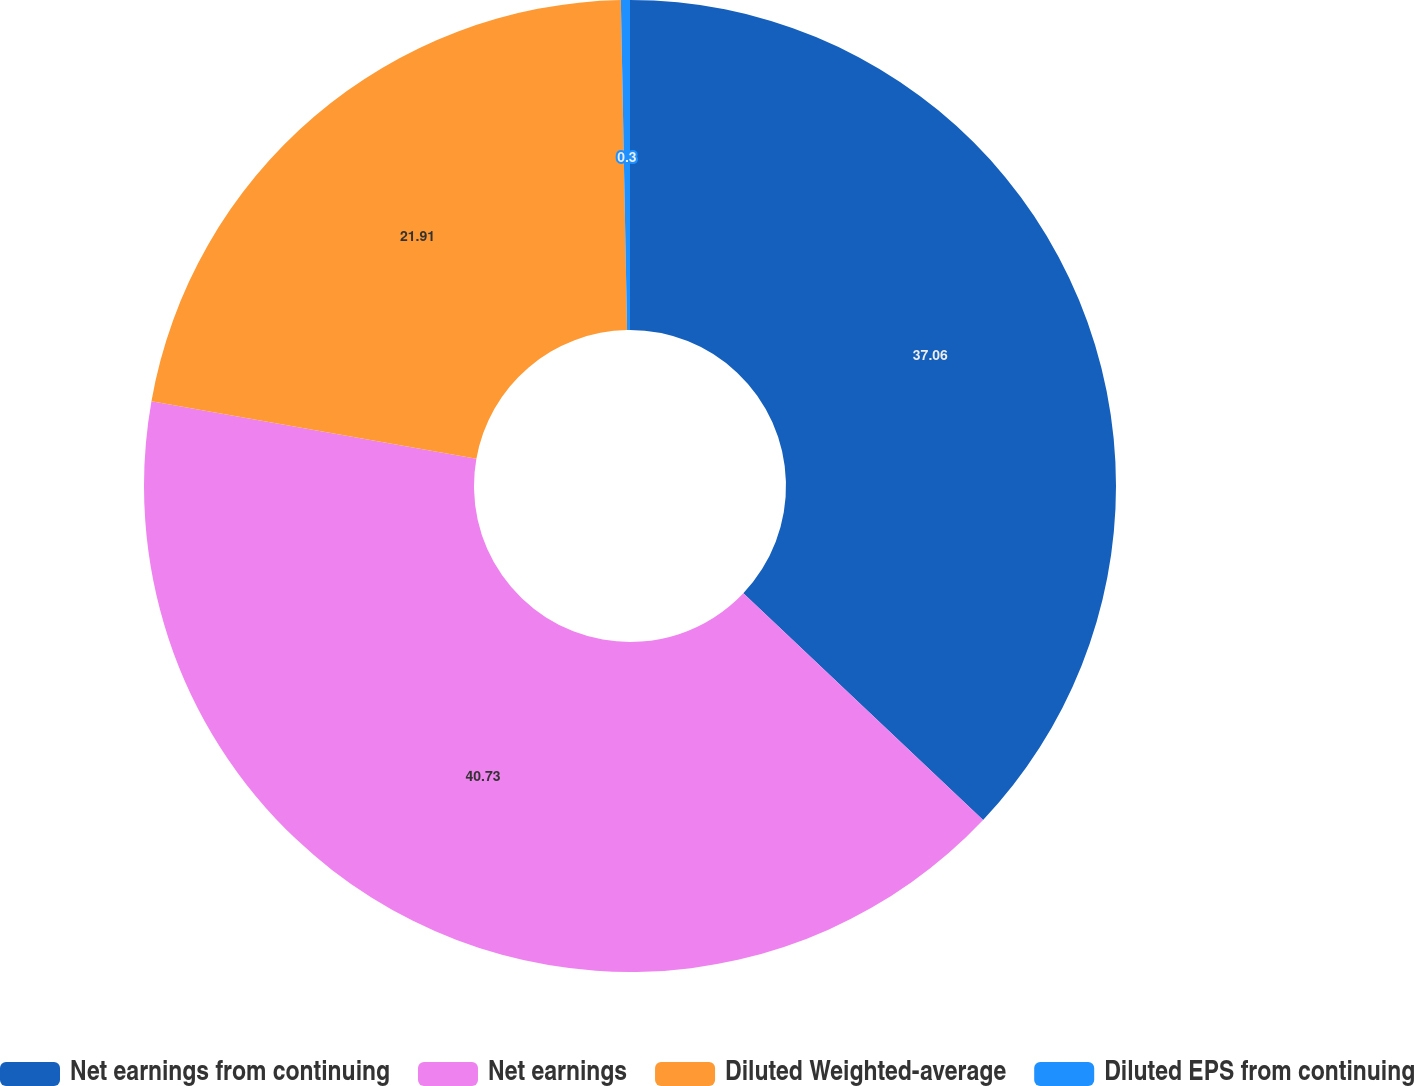Convert chart. <chart><loc_0><loc_0><loc_500><loc_500><pie_chart><fcel>Net earnings from continuing<fcel>Net earnings<fcel>Diluted Weighted-average<fcel>Diluted EPS from continuing<nl><fcel>37.06%<fcel>40.74%<fcel>21.91%<fcel>0.3%<nl></chart> 